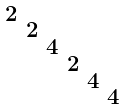<formula> <loc_0><loc_0><loc_500><loc_500>\begin{smallmatrix} 2 & & & & & \\ & 2 & & & & \\ & & 4 & & & \\ & & & 2 & & \\ & & & & 4 & \\ & & & & & 4 \end{smallmatrix}</formula> 